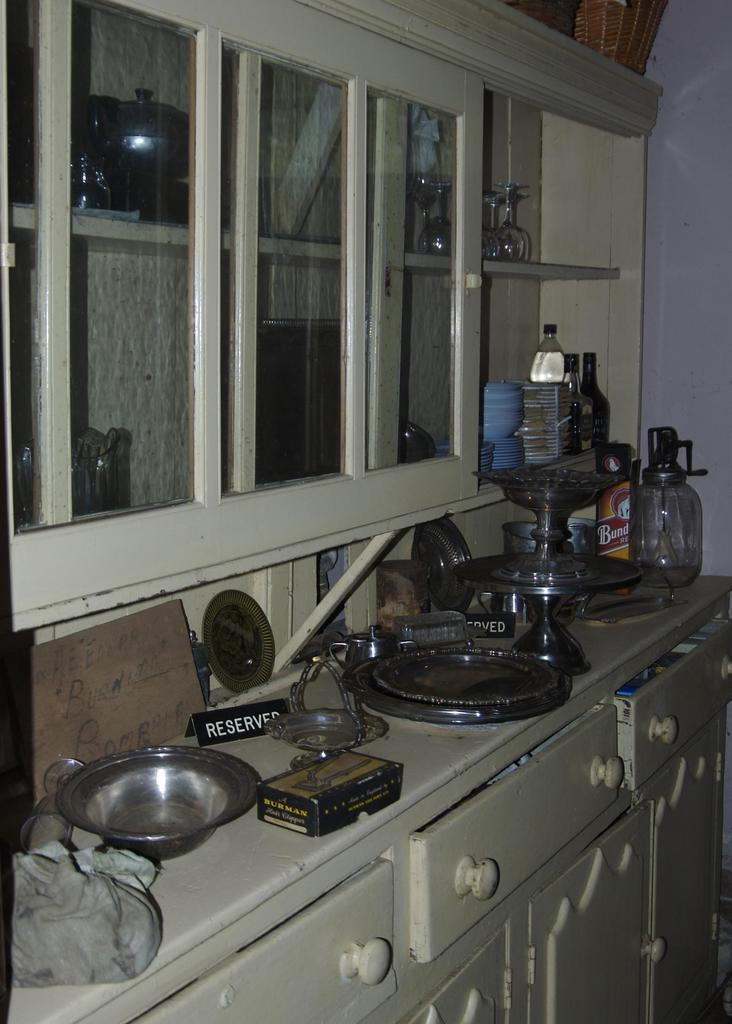<image>
Create a compact narrative representing the image presented. A lot of bowls and plates are sitting out on a counter next to a Reserved sign. 